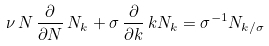<formula> <loc_0><loc_0><loc_500><loc_500>\nu \, N \, \frac { \partial } { \partial N } \, N _ { k } + \sigma \, \frac { \partial } { \partial k } \, k N _ { k } = \sigma ^ { - 1 } N _ { k / \sigma }</formula> 